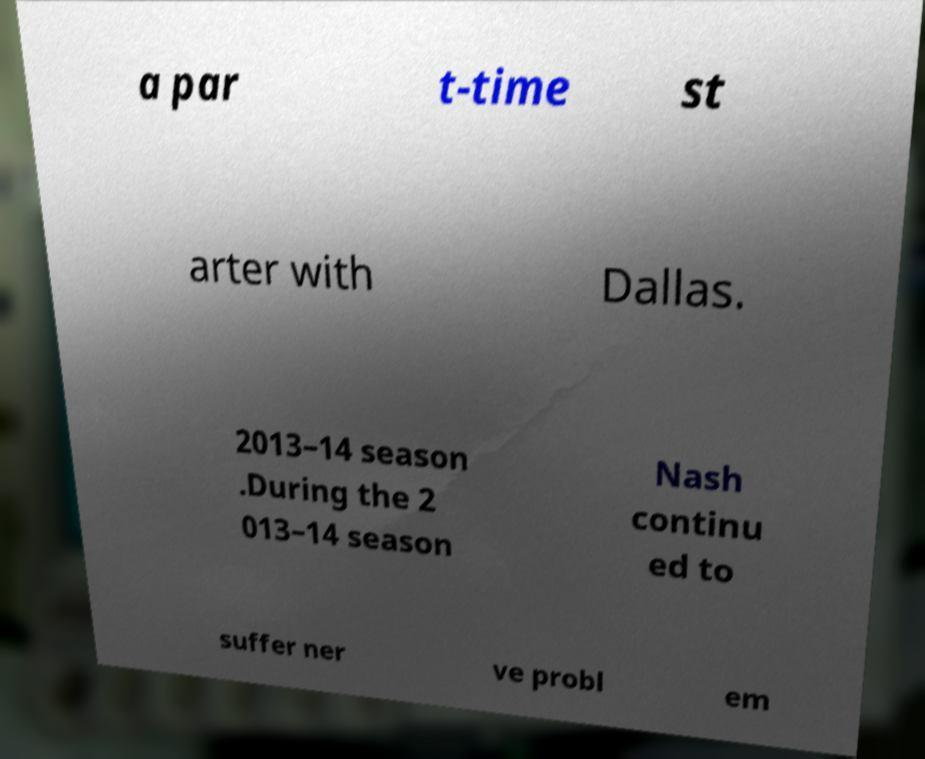Can you read and provide the text displayed in the image?This photo seems to have some interesting text. Can you extract and type it out for me? a par t-time st arter with Dallas. 2013–14 season .During the 2 013–14 season Nash continu ed to suffer ner ve probl em 